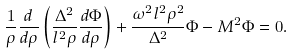Convert formula to latex. <formula><loc_0><loc_0><loc_500><loc_500>\frac { 1 } { \rho } \frac { d } { d \rho } \left ( \frac { \Delta ^ { 2 } } { l ^ { 2 } \rho } \frac { d \Phi } { d \rho } \right ) + \frac { \omega ^ { 2 } l ^ { 2 } \rho ^ { 2 } } { \Delta ^ { 2 } } \Phi - M ^ { 2 } \Phi = 0 .</formula> 